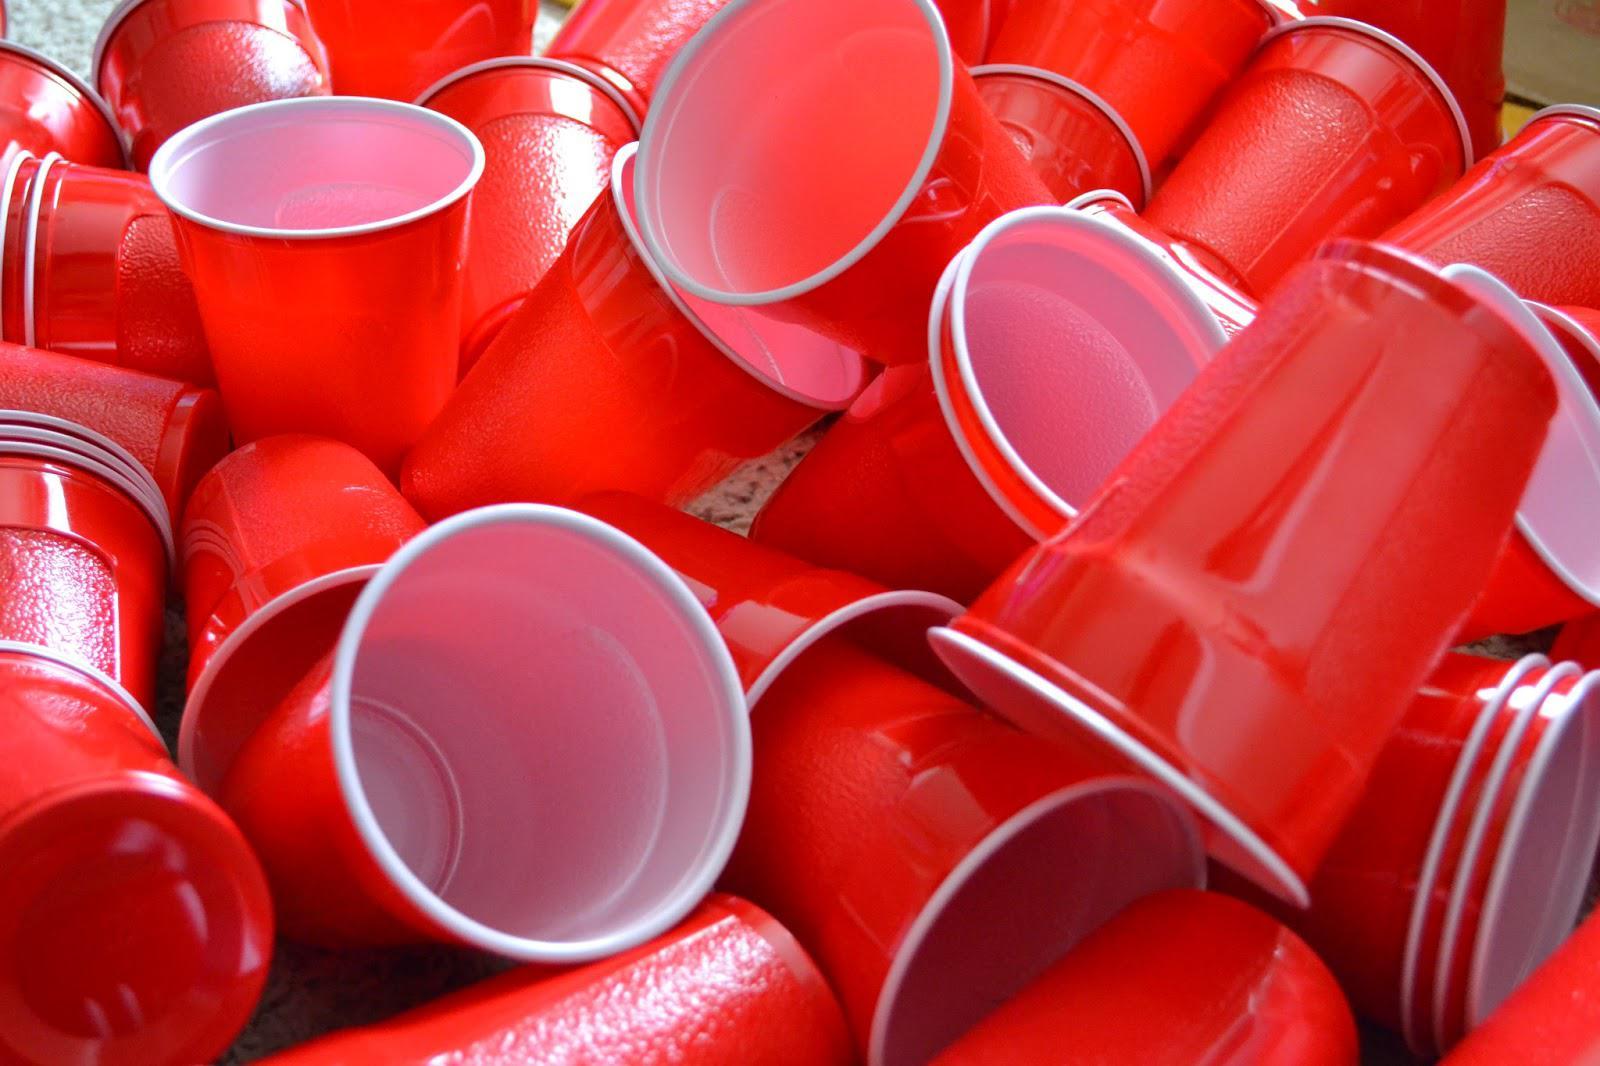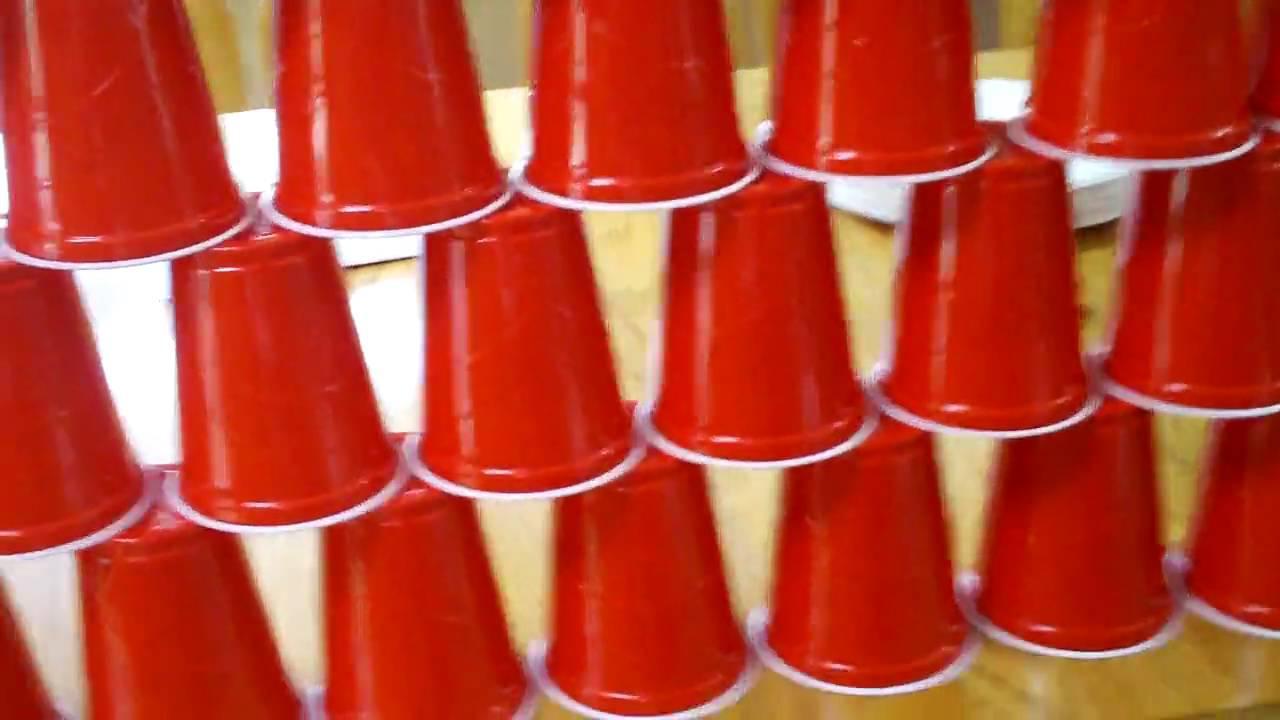The first image is the image on the left, the second image is the image on the right. Analyze the images presented: Is the assertion "The left image features a tower of five stacked red plastic cups, and the right image includes rightside-up and upside-down red cups shapes." valid? Answer yes or no. No. The first image is the image on the left, the second image is the image on the right. Analyze the images presented: Is the assertion "Several red solo cups are stacked nested neatly inside each other." valid? Answer yes or no. No. 